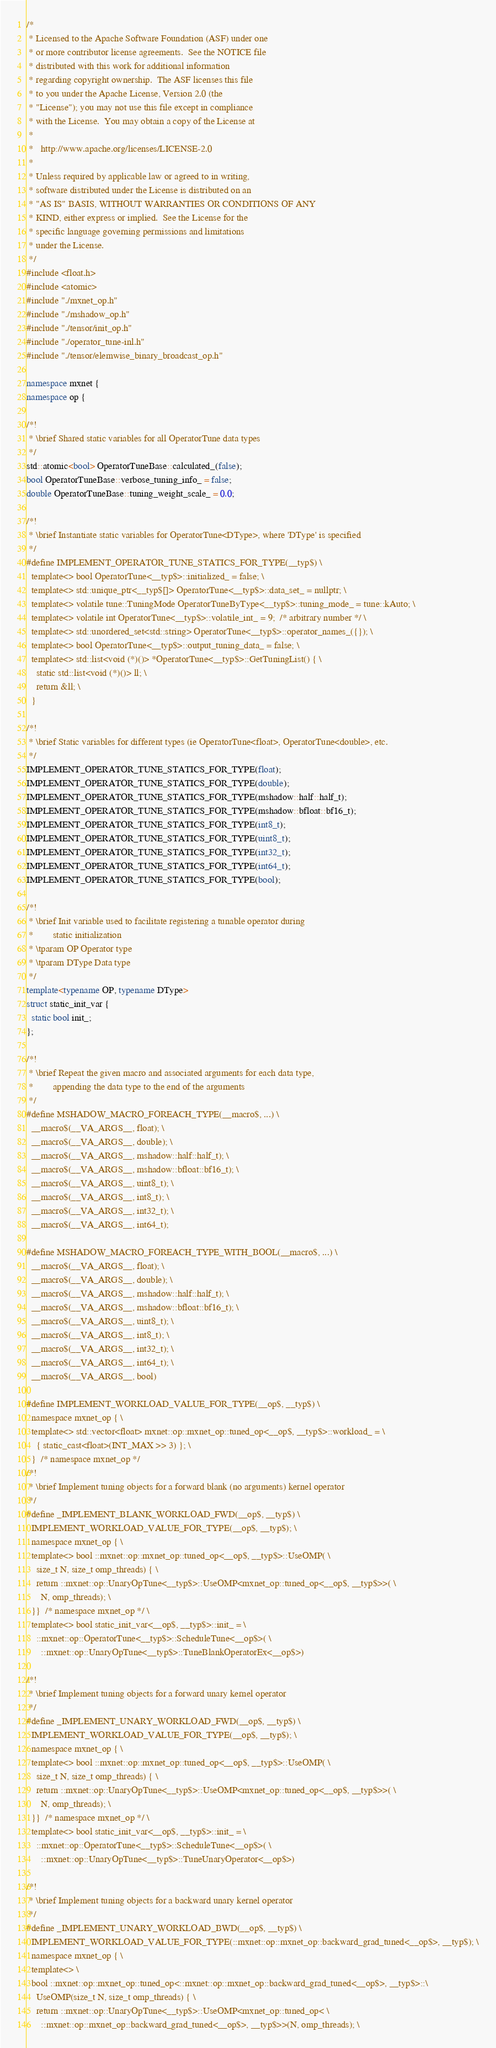Convert code to text. <code><loc_0><loc_0><loc_500><loc_500><_C++_>/*
 * Licensed to the Apache Software Foundation (ASF) under one
 * or more contributor license agreements.  See the NOTICE file
 * distributed with this work for additional information
 * regarding copyright ownership.  The ASF licenses this file
 * to you under the Apache License, Version 2.0 (the
 * "License"); you may not use this file except in compliance
 * with the License.  You may obtain a copy of the License at
 *
 *   http://www.apache.org/licenses/LICENSE-2.0
 *
 * Unless required by applicable law or agreed to in writing,
 * software distributed under the License is distributed on an
 * "AS IS" BASIS, WITHOUT WARRANTIES OR CONDITIONS OF ANY
 * KIND, either express or implied.  See the License for the
 * specific language governing permissions and limitations
 * under the License.
 */
#include <float.h>
#include <atomic>
#include "./mxnet_op.h"
#include "./mshadow_op.h"
#include "./tensor/init_op.h"
#include "./operator_tune-inl.h"
#include "./tensor/elemwise_binary_broadcast_op.h"

namespace mxnet {
namespace op {

/*!
 * \brief Shared static variables for all OperatorTune data types
 */
std::atomic<bool> OperatorTuneBase::calculated_(false);
bool OperatorTuneBase::verbose_tuning_info_ = false;
double OperatorTuneBase::tuning_weight_scale_ = 0.0;

/*!
 * \brief Instantiate static variables for OperatorTune<DType>, where 'DType' is specified
 */
#define IMPLEMENT_OPERATOR_TUNE_STATICS_FOR_TYPE(__typ$) \
  template<> bool OperatorTune<__typ$>::initialized_ = false; \
  template<> std::unique_ptr<__typ$[]> OperatorTune<__typ$>::data_set_ = nullptr; \
  template<> volatile tune::TuningMode OperatorTuneByType<__typ$>::tuning_mode_ = tune::kAuto; \
  template<> volatile int OperatorTune<__typ$>::volatile_int_ = 9;  /* arbitrary number */ \
  template<> std::unordered_set<std::string> OperatorTune<__typ$>::operator_names_({}); \
  template<> bool OperatorTune<__typ$>::output_tuning_data_ = false; \
  template<> std::list<void (*)()> *OperatorTune<__typ$>::GetTuningList() { \
    static std::list<void (*)()> ll; \
    return &ll; \
  }

/*!
 * \brief Static variables for different types (ie OperatorTune<float>, OperatorTune<double>, etc.
 */
IMPLEMENT_OPERATOR_TUNE_STATICS_FOR_TYPE(float);
IMPLEMENT_OPERATOR_TUNE_STATICS_FOR_TYPE(double);
IMPLEMENT_OPERATOR_TUNE_STATICS_FOR_TYPE(mshadow::half::half_t);
IMPLEMENT_OPERATOR_TUNE_STATICS_FOR_TYPE(mshadow::bfloat::bf16_t);
IMPLEMENT_OPERATOR_TUNE_STATICS_FOR_TYPE(int8_t);
IMPLEMENT_OPERATOR_TUNE_STATICS_FOR_TYPE(uint8_t);
IMPLEMENT_OPERATOR_TUNE_STATICS_FOR_TYPE(int32_t);
IMPLEMENT_OPERATOR_TUNE_STATICS_FOR_TYPE(int64_t);
IMPLEMENT_OPERATOR_TUNE_STATICS_FOR_TYPE(bool);

/*!
 * \brief Init variable used to facilitate registering a tunable operator during
 *        static initialization
 * \tparam OP Operator type
 * \tparam DType Data type
 */
template<typename OP, typename DType>
struct static_init_var {
  static bool init_;
};

/*!
 * \brief Repeat the given macro and associated arguments for each data type,
 *        appending the data type to the end of the arguments
 */
#define MSHADOW_MACRO_FOREACH_TYPE(__macro$, ...) \
  __macro$(__VA_ARGS__, float); \
  __macro$(__VA_ARGS__, double); \
  __macro$(__VA_ARGS__, mshadow::half::half_t); \
  __macro$(__VA_ARGS__, mshadow::bfloat::bf16_t); \
  __macro$(__VA_ARGS__, uint8_t); \
  __macro$(__VA_ARGS__, int8_t); \
  __macro$(__VA_ARGS__, int32_t); \
  __macro$(__VA_ARGS__, int64_t);

#define MSHADOW_MACRO_FOREACH_TYPE_WITH_BOOL(__macro$, ...) \
  __macro$(__VA_ARGS__, float); \
  __macro$(__VA_ARGS__, double); \
  __macro$(__VA_ARGS__, mshadow::half::half_t); \
  __macro$(__VA_ARGS__, mshadow::bfloat::bf16_t); \
  __macro$(__VA_ARGS__, uint8_t); \
  __macro$(__VA_ARGS__, int8_t); \
  __macro$(__VA_ARGS__, int32_t); \
  __macro$(__VA_ARGS__, int64_t); \
  __macro$(__VA_ARGS__, bool)

#define IMPLEMENT_WORKLOAD_VALUE_FOR_TYPE(__op$, __typ$) \
  namespace mxnet_op { \
  template<> std::vector<float> mxnet::op::mxnet_op::tuned_op<__op$, __typ$>::workload_ = \
    { static_cast<float>(INT_MAX >> 3) }; \
  }  /* namespace mxnet_op */
/*!
 * \brief Implement tuning objects for a forward blank (no arguments) kernel operator
 */
#define _IMPLEMENT_BLANK_WORKLOAD_FWD(__op$, __typ$) \
  IMPLEMENT_WORKLOAD_VALUE_FOR_TYPE(__op$, __typ$); \
  namespace mxnet_op { \
  template<> bool ::mxnet::op::mxnet_op::tuned_op<__op$, __typ$>::UseOMP( \
    size_t N, size_t omp_threads) { \
    return ::mxnet::op::UnaryOpTune<__typ$>::UseOMP<mxnet_op::tuned_op<__op$, __typ$>>( \
      N, omp_threads); \
  }}  /* namespace mxnet_op */ \
  template<> bool static_init_var<__op$, __typ$>::init_ = \
    ::mxnet::op::OperatorTune<__typ$>::ScheduleTune<__op$>( \
      ::mxnet::op::UnaryOpTune<__typ$>::TuneBlankOperatorEx<__op$>)

/*!
 * \brief Implement tuning objects for a forward unary kernel operator
 */
#define _IMPLEMENT_UNARY_WORKLOAD_FWD(__op$, __typ$) \
  IMPLEMENT_WORKLOAD_VALUE_FOR_TYPE(__op$, __typ$); \
  namespace mxnet_op { \
  template<> bool ::mxnet::op::mxnet_op::tuned_op<__op$, __typ$>::UseOMP( \
    size_t N, size_t omp_threads) { \
    return ::mxnet::op::UnaryOpTune<__typ$>::UseOMP<mxnet_op::tuned_op<__op$, __typ$>>( \
      N, omp_threads); \
  }}  /* namespace mxnet_op */ \
  template<> bool static_init_var<__op$, __typ$>::init_ = \
    ::mxnet::op::OperatorTune<__typ$>::ScheduleTune<__op$>( \
      ::mxnet::op::UnaryOpTune<__typ$>::TuneUnaryOperator<__op$>)

/*!
 * \brief Implement tuning objects for a backward unary kernel operator
 */
#define _IMPLEMENT_UNARY_WORKLOAD_BWD(__op$, __typ$) \
  IMPLEMENT_WORKLOAD_VALUE_FOR_TYPE(::mxnet::op::mxnet_op::backward_grad_tuned<__op$>, __typ$); \
  namespace mxnet_op { \
  template<> \
  bool ::mxnet::op::mxnet_op::tuned_op<::mxnet::op::mxnet_op::backward_grad_tuned<__op$>, __typ$>::\
    UseOMP(size_t N, size_t omp_threads) { \
    return ::mxnet::op::UnaryOpTune<__typ$>::UseOMP<mxnet_op::tuned_op< \
      ::mxnet::op::mxnet_op::backward_grad_tuned<__op$>, __typ$>>(N, omp_threads); \</code> 